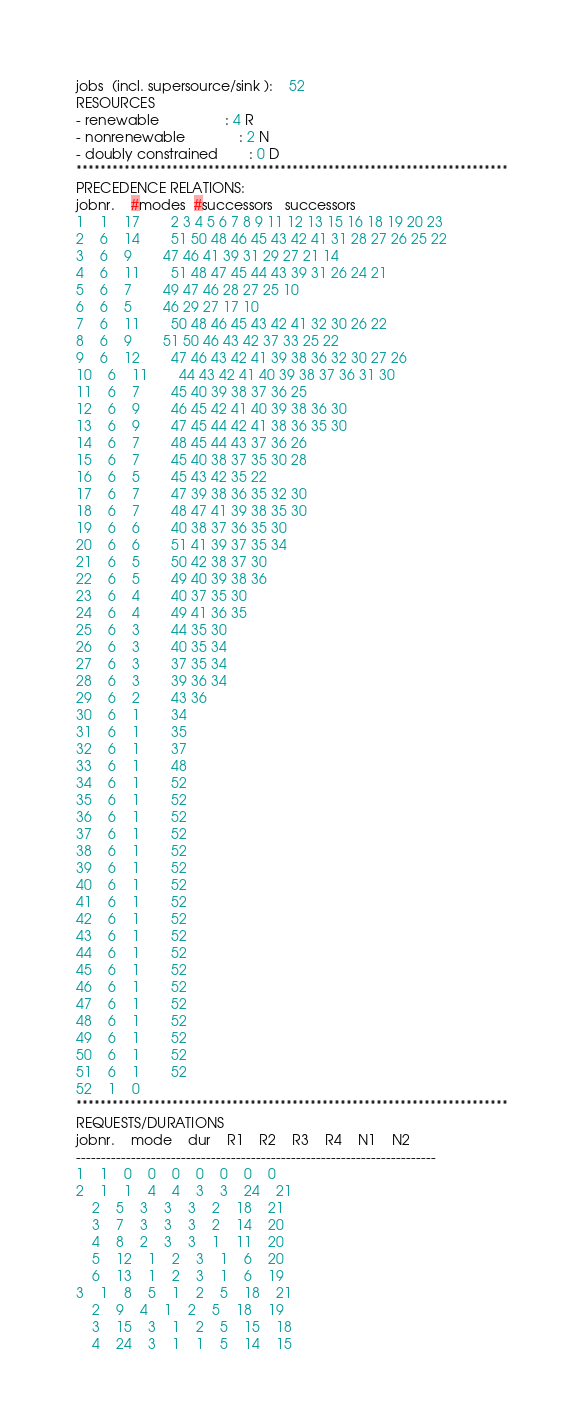<code> <loc_0><loc_0><loc_500><loc_500><_ObjectiveC_>jobs  (incl. supersource/sink ):	52
RESOURCES
- renewable                 : 4 R
- nonrenewable              : 2 N
- doubly constrained        : 0 D
************************************************************************
PRECEDENCE RELATIONS:
jobnr.    #modes  #successors   successors
1	1	17		2 3 4 5 6 7 8 9 11 12 13 15 16 18 19 20 23 
2	6	14		51 50 48 46 45 43 42 41 31 28 27 26 25 22 
3	6	9		47 46 41 39 31 29 27 21 14 
4	6	11		51 48 47 45 44 43 39 31 26 24 21 
5	6	7		49 47 46 28 27 25 10 
6	6	5		46 29 27 17 10 
7	6	11		50 48 46 45 43 42 41 32 30 26 22 
8	6	9		51 50 46 43 42 37 33 25 22 
9	6	12		47 46 43 42 41 39 38 36 32 30 27 26 
10	6	11		44 43 42 41 40 39 38 37 36 31 30 
11	6	7		45 40 39 38 37 36 25 
12	6	9		46 45 42 41 40 39 38 36 30 
13	6	9		47 45 44 42 41 38 36 35 30 
14	6	7		48 45 44 43 37 36 26 
15	6	7		45 40 38 37 35 30 28 
16	6	5		45 43 42 35 22 
17	6	7		47 39 38 36 35 32 30 
18	6	7		48 47 41 39 38 35 30 
19	6	6		40 38 37 36 35 30 
20	6	6		51 41 39 37 35 34 
21	6	5		50 42 38 37 30 
22	6	5		49 40 39 38 36 
23	6	4		40 37 35 30 
24	6	4		49 41 36 35 
25	6	3		44 35 30 
26	6	3		40 35 34 
27	6	3		37 35 34 
28	6	3		39 36 34 
29	6	2		43 36 
30	6	1		34 
31	6	1		35 
32	6	1		37 
33	6	1		48 
34	6	1		52 
35	6	1		52 
36	6	1		52 
37	6	1		52 
38	6	1		52 
39	6	1		52 
40	6	1		52 
41	6	1		52 
42	6	1		52 
43	6	1		52 
44	6	1		52 
45	6	1		52 
46	6	1		52 
47	6	1		52 
48	6	1		52 
49	6	1		52 
50	6	1		52 
51	6	1		52 
52	1	0		
************************************************************************
REQUESTS/DURATIONS
jobnr.	mode	dur	R1	R2	R3	R4	N1	N2	
------------------------------------------------------------------------
1	1	0	0	0	0	0	0	0	
2	1	1	4	4	3	3	24	21	
	2	5	3	3	3	2	18	21	
	3	7	3	3	3	2	14	20	
	4	8	2	3	3	1	11	20	
	5	12	1	2	3	1	6	20	
	6	13	1	2	3	1	6	19	
3	1	8	5	1	2	5	18	21	
	2	9	4	1	2	5	18	19	
	3	15	3	1	2	5	15	18	
	4	24	3	1	1	5	14	15	</code> 